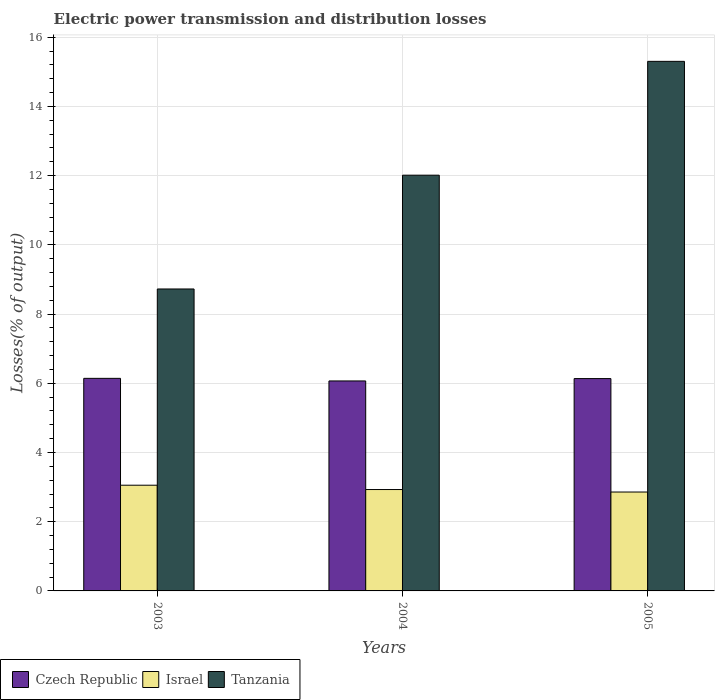Are the number of bars on each tick of the X-axis equal?
Keep it short and to the point. Yes. How many bars are there on the 1st tick from the right?
Provide a short and direct response. 3. What is the label of the 2nd group of bars from the left?
Provide a short and direct response. 2004. What is the electric power transmission and distribution losses in Israel in 2003?
Offer a very short reply. 3.05. Across all years, what is the maximum electric power transmission and distribution losses in Tanzania?
Your response must be concise. 15.3. Across all years, what is the minimum electric power transmission and distribution losses in Tanzania?
Your answer should be very brief. 8.73. In which year was the electric power transmission and distribution losses in Israel maximum?
Give a very brief answer. 2003. In which year was the electric power transmission and distribution losses in Tanzania minimum?
Offer a terse response. 2003. What is the total electric power transmission and distribution losses in Tanzania in the graph?
Your answer should be very brief. 36.04. What is the difference between the electric power transmission and distribution losses in Tanzania in 2004 and that in 2005?
Keep it short and to the point. -3.29. What is the difference between the electric power transmission and distribution losses in Tanzania in 2003 and the electric power transmission and distribution losses in Czech Republic in 2004?
Provide a short and direct response. 2.66. What is the average electric power transmission and distribution losses in Israel per year?
Your response must be concise. 2.95. In the year 2004, what is the difference between the electric power transmission and distribution losses in Czech Republic and electric power transmission and distribution losses in Israel?
Your answer should be compact. 3.14. In how many years, is the electric power transmission and distribution losses in Czech Republic greater than 13.6 %?
Provide a short and direct response. 0. What is the ratio of the electric power transmission and distribution losses in Czech Republic in 2003 to that in 2004?
Your answer should be compact. 1.01. Is the electric power transmission and distribution losses in Israel in 2003 less than that in 2005?
Make the answer very short. No. What is the difference between the highest and the second highest electric power transmission and distribution losses in Czech Republic?
Ensure brevity in your answer.  0.01. What is the difference between the highest and the lowest electric power transmission and distribution losses in Israel?
Offer a terse response. 0.2. Is the sum of the electric power transmission and distribution losses in Tanzania in 2003 and 2004 greater than the maximum electric power transmission and distribution losses in Czech Republic across all years?
Offer a very short reply. Yes. What does the 1st bar from the left in 2005 represents?
Give a very brief answer. Czech Republic. What does the 1st bar from the right in 2003 represents?
Offer a terse response. Tanzania. Is it the case that in every year, the sum of the electric power transmission and distribution losses in Israel and electric power transmission and distribution losses in Czech Republic is greater than the electric power transmission and distribution losses in Tanzania?
Provide a succinct answer. No. How many bars are there?
Your answer should be very brief. 9. Are all the bars in the graph horizontal?
Make the answer very short. No. What is the difference between two consecutive major ticks on the Y-axis?
Offer a very short reply. 2. Are the values on the major ticks of Y-axis written in scientific E-notation?
Ensure brevity in your answer.  No. Where does the legend appear in the graph?
Make the answer very short. Bottom left. What is the title of the graph?
Provide a short and direct response. Electric power transmission and distribution losses. Does "Namibia" appear as one of the legend labels in the graph?
Offer a terse response. No. What is the label or title of the X-axis?
Offer a very short reply. Years. What is the label or title of the Y-axis?
Give a very brief answer. Losses(% of output). What is the Losses(% of output) in Czech Republic in 2003?
Offer a very short reply. 6.14. What is the Losses(% of output) of Israel in 2003?
Give a very brief answer. 3.05. What is the Losses(% of output) of Tanzania in 2003?
Keep it short and to the point. 8.73. What is the Losses(% of output) of Czech Republic in 2004?
Your answer should be very brief. 6.07. What is the Losses(% of output) of Israel in 2004?
Your response must be concise. 2.93. What is the Losses(% of output) of Tanzania in 2004?
Your answer should be compact. 12.01. What is the Losses(% of output) in Czech Republic in 2005?
Your answer should be compact. 6.14. What is the Losses(% of output) in Israel in 2005?
Make the answer very short. 2.86. What is the Losses(% of output) in Tanzania in 2005?
Your response must be concise. 15.3. Across all years, what is the maximum Losses(% of output) of Czech Republic?
Your answer should be compact. 6.14. Across all years, what is the maximum Losses(% of output) in Israel?
Offer a terse response. 3.05. Across all years, what is the maximum Losses(% of output) in Tanzania?
Provide a succinct answer. 15.3. Across all years, what is the minimum Losses(% of output) in Czech Republic?
Provide a succinct answer. 6.07. Across all years, what is the minimum Losses(% of output) of Israel?
Offer a very short reply. 2.86. Across all years, what is the minimum Losses(% of output) in Tanzania?
Your answer should be compact. 8.73. What is the total Losses(% of output) of Czech Republic in the graph?
Keep it short and to the point. 18.35. What is the total Losses(% of output) in Israel in the graph?
Your answer should be very brief. 8.84. What is the total Losses(% of output) of Tanzania in the graph?
Offer a very short reply. 36.04. What is the difference between the Losses(% of output) of Czech Republic in 2003 and that in 2004?
Your response must be concise. 0.07. What is the difference between the Losses(% of output) in Israel in 2003 and that in 2004?
Make the answer very short. 0.13. What is the difference between the Losses(% of output) of Tanzania in 2003 and that in 2004?
Your answer should be compact. -3.29. What is the difference between the Losses(% of output) in Czech Republic in 2003 and that in 2005?
Make the answer very short. 0.01. What is the difference between the Losses(% of output) of Israel in 2003 and that in 2005?
Make the answer very short. 0.2. What is the difference between the Losses(% of output) in Tanzania in 2003 and that in 2005?
Offer a terse response. -6.58. What is the difference between the Losses(% of output) of Czech Republic in 2004 and that in 2005?
Make the answer very short. -0.07. What is the difference between the Losses(% of output) of Israel in 2004 and that in 2005?
Provide a short and direct response. 0.07. What is the difference between the Losses(% of output) in Tanzania in 2004 and that in 2005?
Keep it short and to the point. -3.29. What is the difference between the Losses(% of output) of Czech Republic in 2003 and the Losses(% of output) of Israel in 2004?
Give a very brief answer. 3.21. What is the difference between the Losses(% of output) in Czech Republic in 2003 and the Losses(% of output) in Tanzania in 2004?
Your response must be concise. -5.87. What is the difference between the Losses(% of output) in Israel in 2003 and the Losses(% of output) in Tanzania in 2004?
Keep it short and to the point. -8.96. What is the difference between the Losses(% of output) in Czech Republic in 2003 and the Losses(% of output) in Israel in 2005?
Give a very brief answer. 3.28. What is the difference between the Losses(% of output) in Czech Republic in 2003 and the Losses(% of output) in Tanzania in 2005?
Your response must be concise. -9.16. What is the difference between the Losses(% of output) in Israel in 2003 and the Losses(% of output) in Tanzania in 2005?
Your response must be concise. -12.25. What is the difference between the Losses(% of output) in Czech Republic in 2004 and the Losses(% of output) in Israel in 2005?
Ensure brevity in your answer.  3.21. What is the difference between the Losses(% of output) of Czech Republic in 2004 and the Losses(% of output) of Tanzania in 2005?
Keep it short and to the point. -9.23. What is the difference between the Losses(% of output) in Israel in 2004 and the Losses(% of output) in Tanzania in 2005?
Provide a succinct answer. -12.37. What is the average Losses(% of output) in Czech Republic per year?
Offer a terse response. 6.12. What is the average Losses(% of output) of Israel per year?
Provide a short and direct response. 2.95. What is the average Losses(% of output) in Tanzania per year?
Your answer should be very brief. 12.01. In the year 2003, what is the difference between the Losses(% of output) in Czech Republic and Losses(% of output) in Israel?
Keep it short and to the point. 3.09. In the year 2003, what is the difference between the Losses(% of output) of Czech Republic and Losses(% of output) of Tanzania?
Provide a short and direct response. -2.58. In the year 2003, what is the difference between the Losses(% of output) of Israel and Losses(% of output) of Tanzania?
Your answer should be very brief. -5.67. In the year 2004, what is the difference between the Losses(% of output) of Czech Republic and Losses(% of output) of Israel?
Offer a terse response. 3.14. In the year 2004, what is the difference between the Losses(% of output) of Czech Republic and Losses(% of output) of Tanzania?
Your response must be concise. -5.95. In the year 2004, what is the difference between the Losses(% of output) in Israel and Losses(% of output) in Tanzania?
Make the answer very short. -9.08. In the year 2005, what is the difference between the Losses(% of output) in Czech Republic and Losses(% of output) in Israel?
Your response must be concise. 3.28. In the year 2005, what is the difference between the Losses(% of output) of Czech Republic and Losses(% of output) of Tanzania?
Offer a very short reply. -9.17. In the year 2005, what is the difference between the Losses(% of output) of Israel and Losses(% of output) of Tanzania?
Provide a succinct answer. -12.44. What is the ratio of the Losses(% of output) of Czech Republic in 2003 to that in 2004?
Give a very brief answer. 1.01. What is the ratio of the Losses(% of output) of Israel in 2003 to that in 2004?
Your answer should be compact. 1.04. What is the ratio of the Losses(% of output) of Tanzania in 2003 to that in 2004?
Your answer should be compact. 0.73. What is the ratio of the Losses(% of output) of Israel in 2003 to that in 2005?
Make the answer very short. 1.07. What is the ratio of the Losses(% of output) in Tanzania in 2003 to that in 2005?
Provide a short and direct response. 0.57. What is the ratio of the Losses(% of output) of Czech Republic in 2004 to that in 2005?
Provide a succinct answer. 0.99. What is the ratio of the Losses(% of output) of Israel in 2004 to that in 2005?
Your answer should be compact. 1.02. What is the ratio of the Losses(% of output) of Tanzania in 2004 to that in 2005?
Keep it short and to the point. 0.79. What is the difference between the highest and the second highest Losses(% of output) in Czech Republic?
Provide a succinct answer. 0.01. What is the difference between the highest and the second highest Losses(% of output) in Israel?
Make the answer very short. 0.13. What is the difference between the highest and the second highest Losses(% of output) in Tanzania?
Your answer should be very brief. 3.29. What is the difference between the highest and the lowest Losses(% of output) in Czech Republic?
Keep it short and to the point. 0.07. What is the difference between the highest and the lowest Losses(% of output) of Israel?
Your answer should be compact. 0.2. What is the difference between the highest and the lowest Losses(% of output) in Tanzania?
Provide a short and direct response. 6.58. 